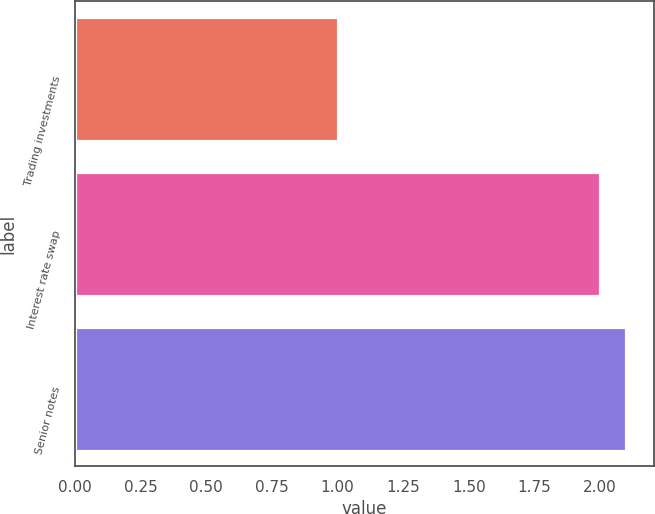<chart> <loc_0><loc_0><loc_500><loc_500><bar_chart><fcel>Trading investments<fcel>Interest rate swap<fcel>Senior notes<nl><fcel>1<fcel>2<fcel>2.1<nl></chart> 